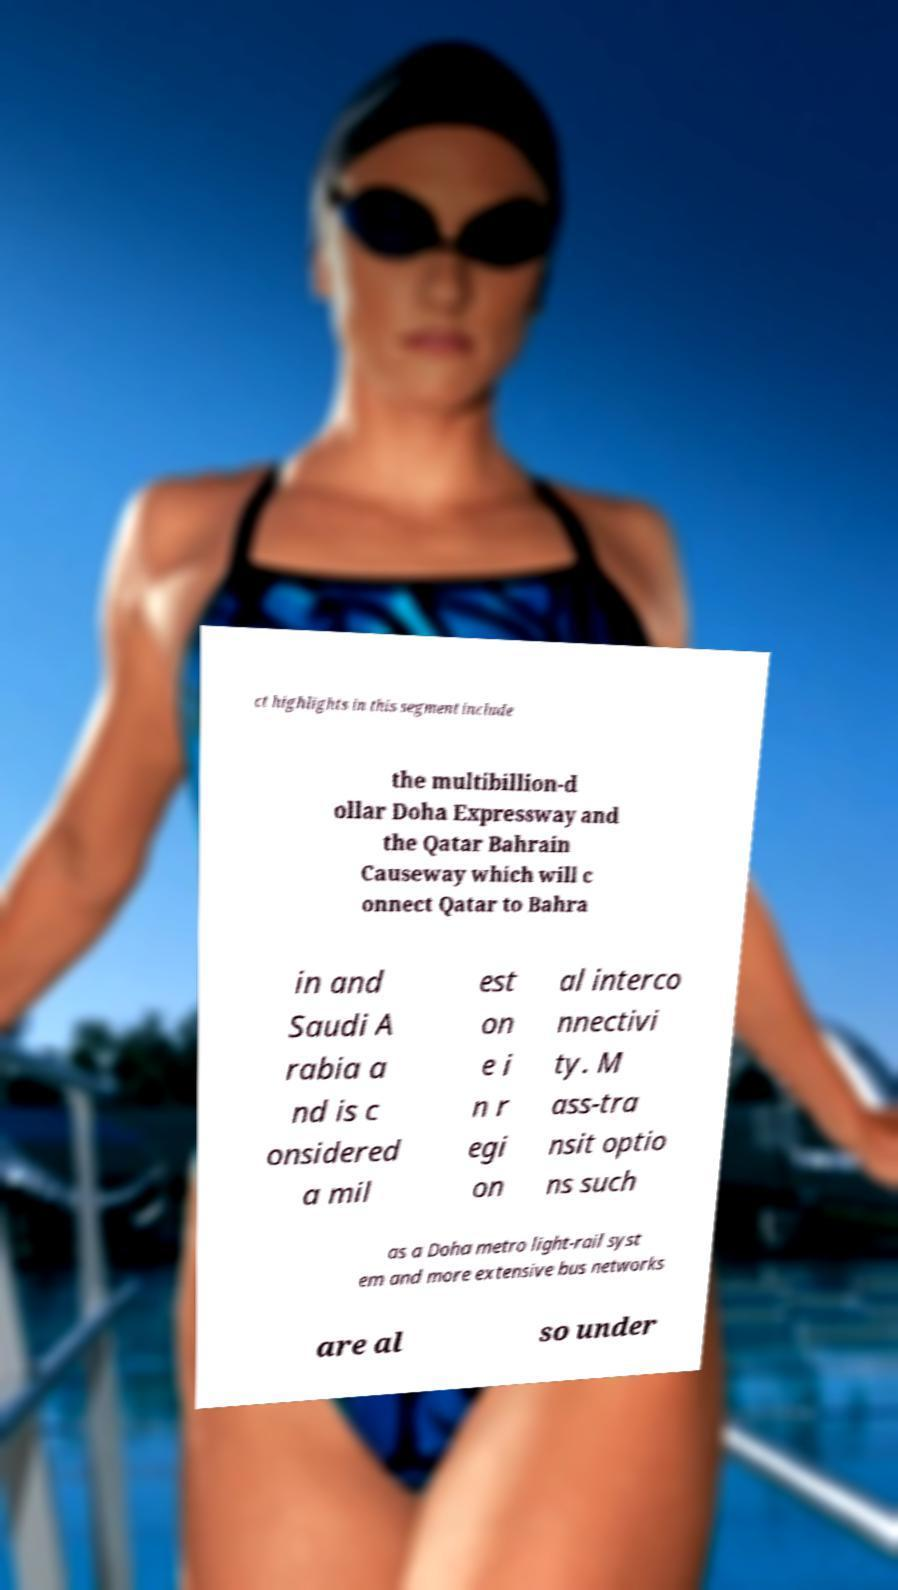There's text embedded in this image that I need extracted. Can you transcribe it verbatim? ct highlights in this segment include the multibillion-d ollar Doha Expressway and the Qatar Bahrain Causeway which will c onnect Qatar to Bahra in and Saudi A rabia a nd is c onsidered a mil est on e i n r egi on al interco nnectivi ty. M ass-tra nsit optio ns such as a Doha metro light-rail syst em and more extensive bus networks are al so under 